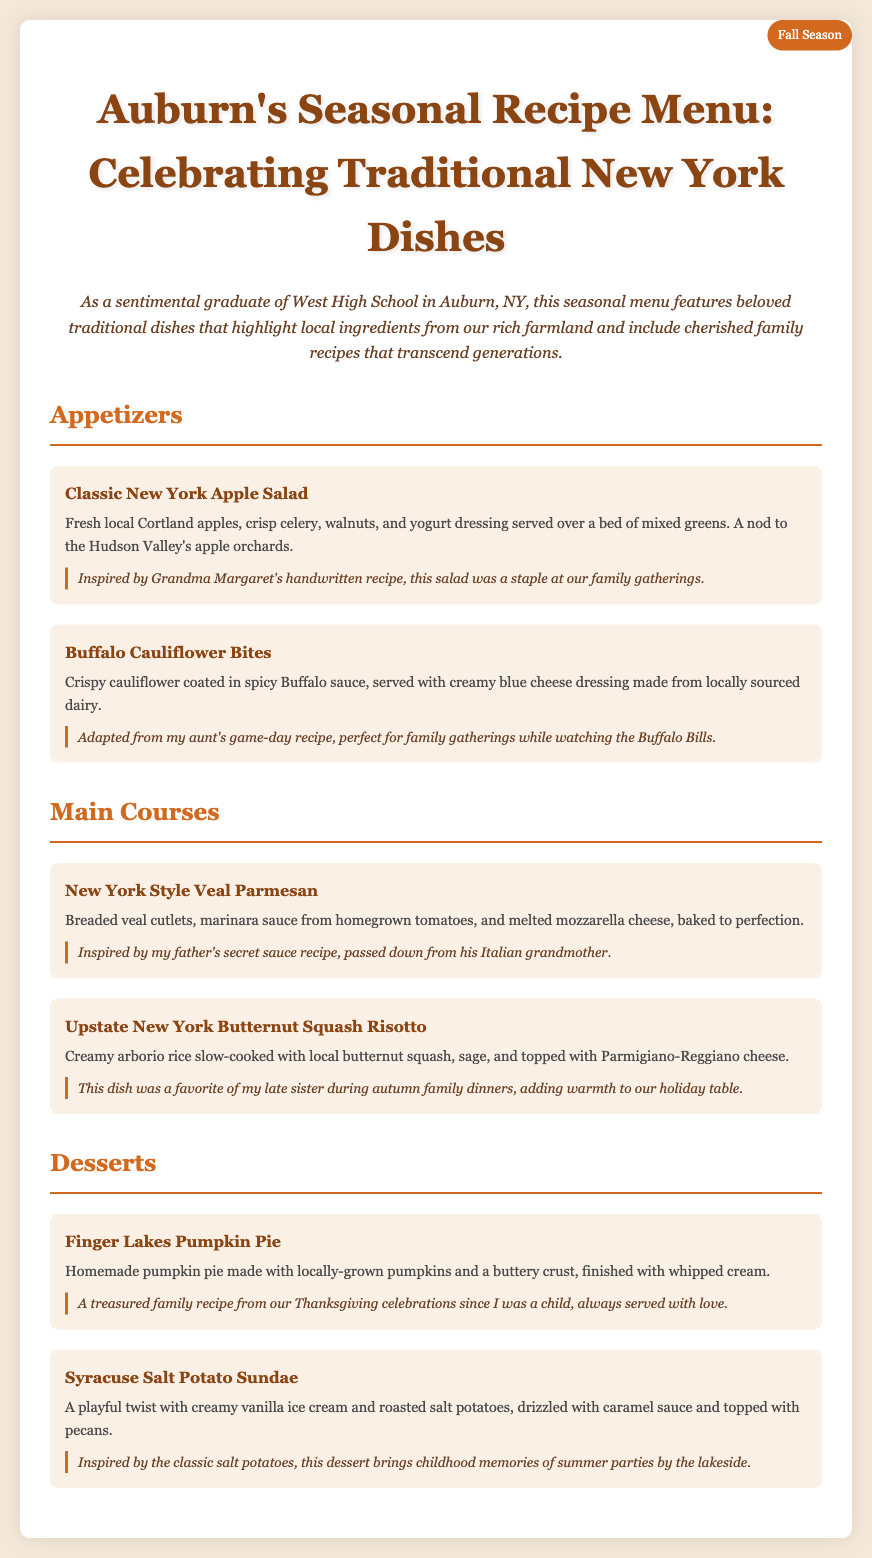What is the title of the menu? The title of the menu is prominently displayed at the top of the document, which is "Auburn's Seasonal Recipe Menu: Celebrating Traditional New York Dishes."
Answer: Auburn's Seasonal Recipe Menu: Celebrating Traditional New York Dishes What season does the menu celebrate? The document indicates the menu is focused on the "Fall Season," labeled in the top right corner.
Answer: Fall Season How many appetizers are listed in the menu? The document contains two appetizers listed under the "Appetizers" section.
Answer: 2 What ingredient is prominently featured in the Classic New York Apple Salad? The salad prominently features "fresh local Cortland apples," as described in the item description.
Answer: fresh local Cortland apples Who inspired the recipe for the Syracuse Salt Potato Sundae? The dessert was inspired by "the classic salt potatoes," connecting to memories of childhood summer parties.
Answer: the classic salt potatoes What is the main ingredient in the New York Style Veal Parmesan? The primary ingredient of the dish, as cited in the description, is "breaded veal cutlets."
Answer: breaded veal cutlets Which dessert is associated with Thanksgiving celebrations? The dessert associated with Thanksgiving celebrations is "Finger Lakes Pumpkin Pie," highlighted in the personal touch section.
Answer: Finger Lakes Pumpkin Pie What type of cheese tops the Upstate New York Butternut Squash Risotto? The risotto is topped with "Parmigiano-Reggiano cheese," mentioned in the dish description.
Answer: Parmigiano-Reggiano cheese What type of dressing is served with the Buffalo Cauliflower Bites? The dish is served with "creamy blue cheese dressing," as stated in the item description.
Answer: creamy blue cheese dressing 